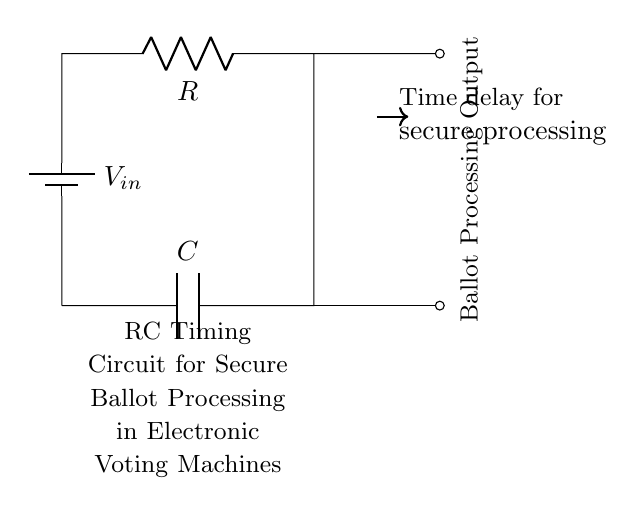What are the components in the circuit? The circuit contains a battery (voltage source), a resistor (R), and a capacitor (C). These are the primary components that work together in the RC timing circuit.
Answer: Battery, Resistor, Capacitor What type of circuit is this? This is an RC timing circuit, specifically designed for timing applications, where a resistor and capacitor are used to create a time delay.
Answer: RC timing circuit What is the function of the resistor in this circuit? The resistor limits the current flow, affecting the charging and discharging rate of the capacitor, which is essential for determining the timing characteristics of the circuit.
Answer: Current limiting How does the capacitor affect the timing function? The capacitor stores electrical energy and its charging and discharging through the resistor determines the time delay for secure ballot processing, making it a crucial element in the timing mechanism.
Answer: Timing delay What does the output indicate? The output provides a signal that correlates with the timing of the capacitor's charge and discharge processes, indicating when secure processing is completed.
Answer: Ballot Processing Output How can you calculate the time constant of this circuit? The time constant, denoted by tau (τ), is calculated by multiplying the resistance (R) by the capacitance (C) in seconds, which will give the time it takes for the capacitor to charge to approximately 63.2 percent of the input voltage.
Answer: R times C 